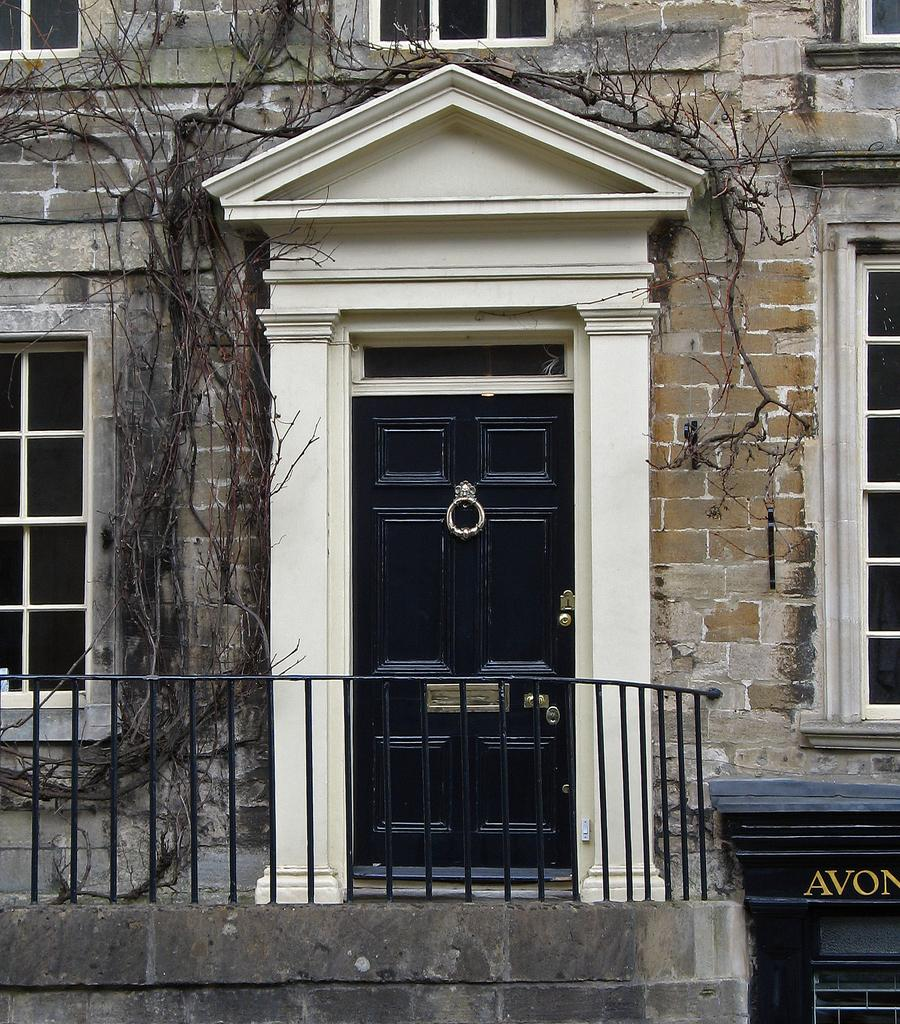What is the main subject of the image? The main subject of the image is a building. What features can be seen on the building? The building has a door, windows, and a railing. Is there any vegetation visible in the image? Yes, there is a tree visible in the image. Can you see a frog sitting on the railing in the image? No, there is no frog present in the image. Is there a fireman standing near the building in the image? No, there is no fireman present in the image. 